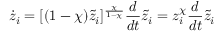<formula> <loc_0><loc_0><loc_500><loc_500>\dot { z } _ { i } = [ ( 1 - \chi ) \tilde { z } _ { i } ] ^ { \frac { \chi } { 1 - \chi } } \frac { d } { d t } \tilde { z } _ { i } = z _ { i } ^ { \chi } \frac { d } { d t } \tilde { z } _ { i }</formula> 